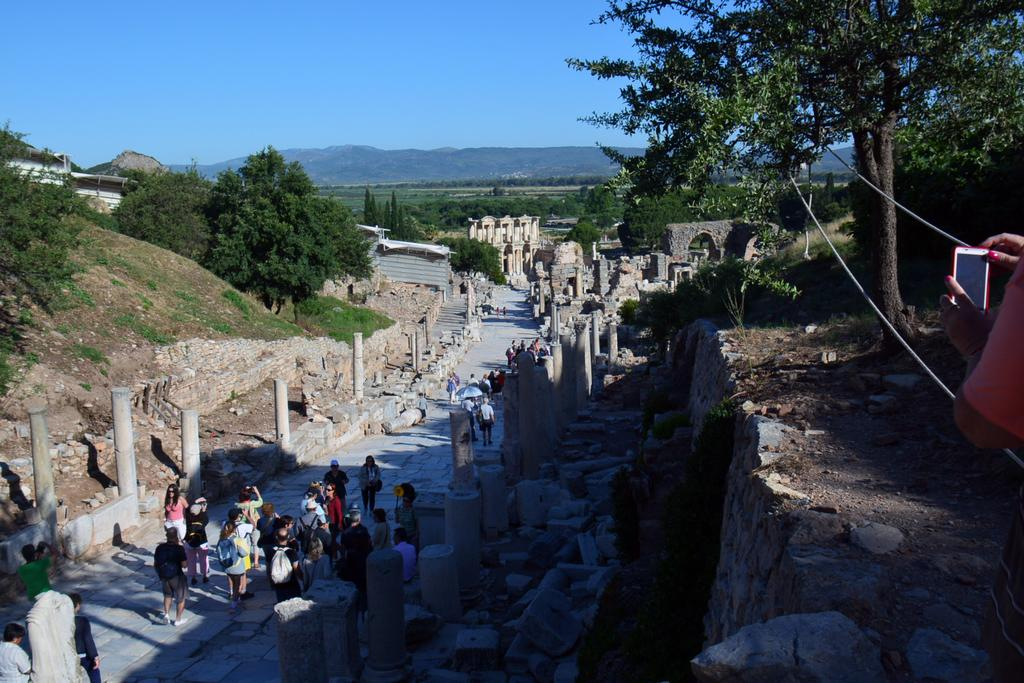What type of structure is visible in the image? There is a fort in the image. What architectural features can be seen in the image? There are pillars in the image. What natural elements are present in the image? There are trees, rocks, and mountains in the image. What are the people in the image doing? Some people in the image are walking. What are the people wearing that might be used for carrying items? Some people in the image are wearing bags. What is the color of the sky in the image? The sky is in white and blue color. What type of juice can be seen being squeezed from the trees in the image? There is no juice being squeezed from the trees in the image; the trees are simply present in the natural landscape. How many men are visible in the image? The provided facts do not specify the number of men or any specific gender in the image, so it cannot be determined from the image. 